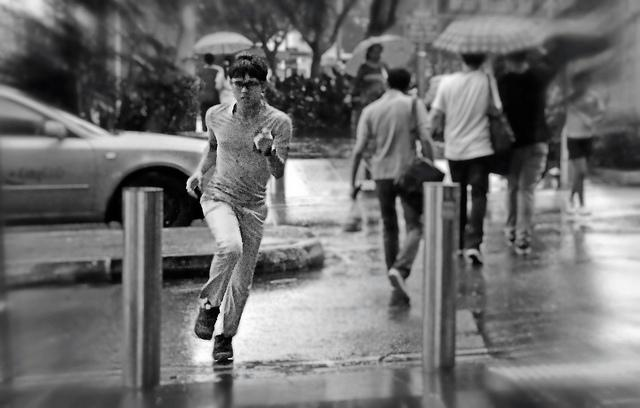What is the boy running through? Please explain your reasoning. rain. This is evident given the umbrellas people are using and the glossy appearance of the street. 